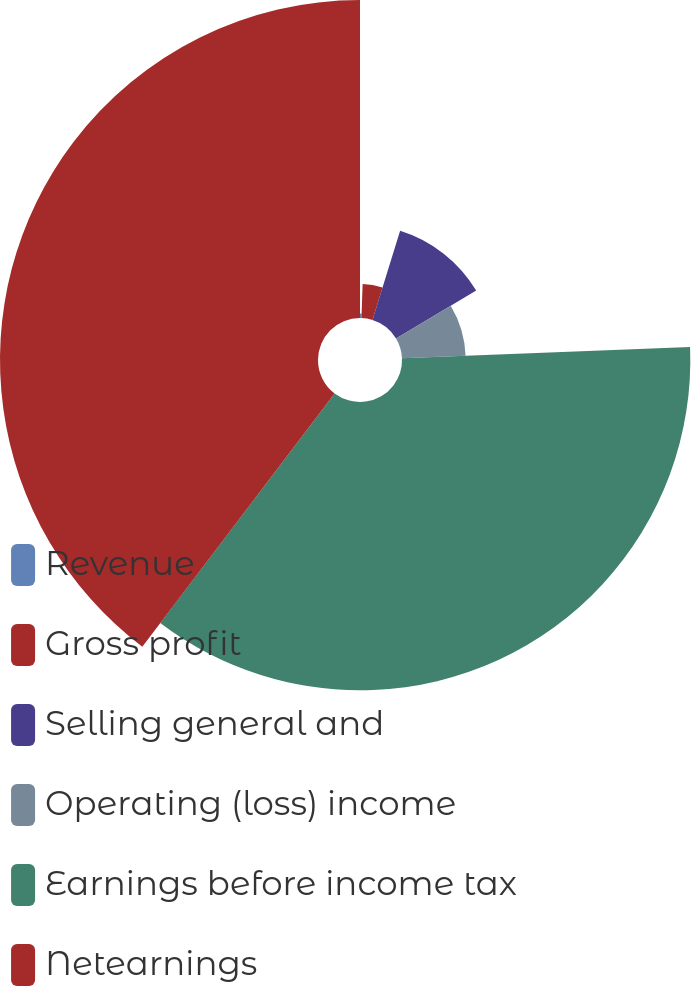Convert chart to OTSL. <chart><loc_0><loc_0><loc_500><loc_500><pie_chart><fcel>Revenue<fcel>Gross profit<fcel>Selling general and<fcel>Operating (loss) income<fcel>Earnings before income tax<fcel>Netearnings<nl><fcel>0.55%<fcel>4.24%<fcel>11.64%<fcel>7.94%<fcel>35.96%<fcel>39.66%<nl></chart> 